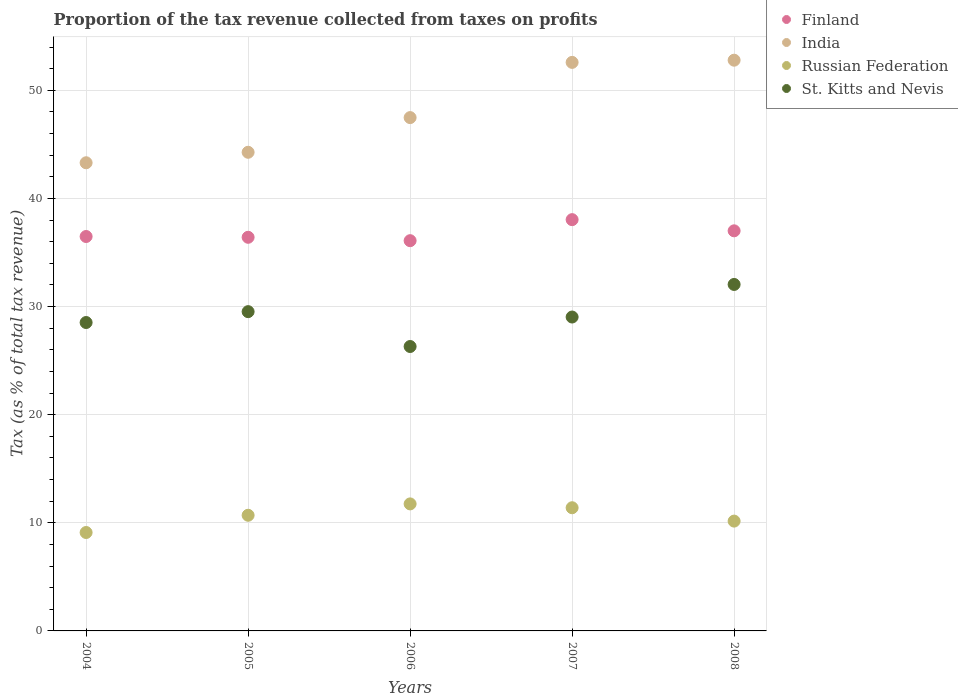How many different coloured dotlines are there?
Your response must be concise. 4. Is the number of dotlines equal to the number of legend labels?
Give a very brief answer. Yes. What is the proportion of the tax revenue collected in India in 2004?
Your response must be concise. 43.3. Across all years, what is the maximum proportion of the tax revenue collected in Finland?
Offer a very short reply. 38.03. Across all years, what is the minimum proportion of the tax revenue collected in India?
Give a very brief answer. 43.3. In which year was the proportion of the tax revenue collected in India maximum?
Keep it short and to the point. 2008. In which year was the proportion of the tax revenue collected in India minimum?
Ensure brevity in your answer.  2004. What is the total proportion of the tax revenue collected in Russian Federation in the graph?
Offer a terse response. 53.09. What is the difference between the proportion of the tax revenue collected in St. Kitts and Nevis in 2006 and that in 2007?
Provide a succinct answer. -2.73. What is the difference between the proportion of the tax revenue collected in St. Kitts and Nevis in 2004 and the proportion of the tax revenue collected in India in 2005?
Keep it short and to the point. -15.74. What is the average proportion of the tax revenue collected in Finland per year?
Provide a short and direct response. 36.8. In the year 2004, what is the difference between the proportion of the tax revenue collected in St. Kitts and Nevis and proportion of the tax revenue collected in Russian Federation?
Give a very brief answer. 19.42. In how many years, is the proportion of the tax revenue collected in India greater than 14 %?
Your answer should be compact. 5. What is the ratio of the proportion of the tax revenue collected in Russian Federation in 2006 to that in 2007?
Provide a short and direct response. 1.03. Is the proportion of the tax revenue collected in St. Kitts and Nevis in 2004 less than that in 2008?
Ensure brevity in your answer.  Yes. What is the difference between the highest and the second highest proportion of the tax revenue collected in Finland?
Your answer should be very brief. 1.03. What is the difference between the highest and the lowest proportion of the tax revenue collected in Russian Federation?
Keep it short and to the point. 2.65. In how many years, is the proportion of the tax revenue collected in India greater than the average proportion of the tax revenue collected in India taken over all years?
Offer a very short reply. 2. Is the sum of the proportion of the tax revenue collected in St. Kitts and Nevis in 2004 and 2006 greater than the maximum proportion of the tax revenue collected in Russian Federation across all years?
Keep it short and to the point. Yes. Is the proportion of the tax revenue collected in Finland strictly less than the proportion of the tax revenue collected in Russian Federation over the years?
Give a very brief answer. No. How many dotlines are there?
Give a very brief answer. 4. Does the graph contain grids?
Offer a terse response. Yes. How many legend labels are there?
Ensure brevity in your answer.  4. What is the title of the graph?
Keep it short and to the point. Proportion of the tax revenue collected from taxes on profits. What is the label or title of the Y-axis?
Your answer should be very brief. Tax (as % of total tax revenue). What is the Tax (as % of total tax revenue) of Finland in 2004?
Your answer should be compact. 36.48. What is the Tax (as % of total tax revenue) in India in 2004?
Your answer should be compact. 43.3. What is the Tax (as % of total tax revenue) in Russian Federation in 2004?
Offer a very short reply. 9.1. What is the Tax (as % of total tax revenue) of St. Kitts and Nevis in 2004?
Provide a short and direct response. 28.52. What is the Tax (as % of total tax revenue) of Finland in 2005?
Provide a succinct answer. 36.4. What is the Tax (as % of total tax revenue) in India in 2005?
Provide a succinct answer. 44.27. What is the Tax (as % of total tax revenue) of Russian Federation in 2005?
Give a very brief answer. 10.7. What is the Tax (as % of total tax revenue) in St. Kitts and Nevis in 2005?
Provide a succinct answer. 29.53. What is the Tax (as % of total tax revenue) in Finland in 2006?
Provide a succinct answer. 36.09. What is the Tax (as % of total tax revenue) in India in 2006?
Ensure brevity in your answer.  47.47. What is the Tax (as % of total tax revenue) in Russian Federation in 2006?
Keep it short and to the point. 11.75. What is the Tax (as % of total tax revenue) of St. Kitts and Nevis in 2006?
Ensure brevity in your answer.  26.3. What is the Tax (as % of total tax revenue) of Finland in 2007?
Your response must be concise. 38.03. What is the Tax (as % of total tax revenue) of India in 2007?
Make the answer very short. 52.58. What is the Tax (as % of total tax revenue) of Russian Federation in 2007?
Make the answer very short. 11.39. What is the Tax (as % of total tax revenue) in St. Kitts and Nevis in 2007?
Keep it short and to the point. 29.03. What is the Tax (as % of total tax revenue) in Finland in 2008?
Your answer should be compact. 37. What is the Tax (as % of total tax revenue) of India in 2008?
Your answer should be compact. 52.78. What is the Tax (as % of total tax revenue) of Russian Federation in 2008?
Provide a short and direct response. 10.16. What is the Tax (as % of total tax revenue) of St. Kitts and Nevis in 2008?
Offer a terse response. 32.04. Across all years, what is the maximum Tax (as % of total tax revenue) in Finland?
Make the answer very short. 38.03. Across all years, what is the maximum Tax (as % of total tax revenue) of India?
Offer a very short reply. 52.78. Across all years, what is the maximum Tax (as % of total tax revenue) in Russian Federation?
Provide a short and direct response. 11.75. Across all years, what is the maximum Tax (as % of total tax revenue) of St. Kitts and Nevis?
Provide a succinct answer. 32.04. Across all years, what is the minimum Tax (as % of total tax revenue) in Finland?
Offer a very short reply. 36.09. Across all years, what is the minimum Tax (as % of total tax revenue) of India?
Offer a terse response. 43.3. Across all years, what is the minimum Tax (as % of total tax revenue) of Russian Federation?
Your response must be concise. 9.1. Across all years, what is the minimum Tax (as % of total tax revenue) of St. Kitts and Nevis?
Ensure brevity in your answer.  26.3. What is the total Tax (as % of total tax revenue) of Finland in the graph?
Provide a succinct answer. 184.01. What is the total Tax (as % of total tax revenue) of India in the graph?
Your response must be concise. 240.39. What is the total Tax (as % of total tax revenue) in Russian Federation in the graph?
Your response must be concise. 53.09. What is the total Tax (as % of total tax revenue) of St. Kitts and Nevis in the graph?
Make the answer very short. 145.42. What is the difference between the Tax (as % of total tax revenue) of Finland in 2004 and that in 2005?
Provide a short and direct response. 0.07. What is the difference between the Tax (as % of total tax revenue) in India in 2004 and that in 2005?
Keep it short and to the point. -0.97. What is the difference between the Tax (as % of total tax revenue) of Russian Federation in 2004 and that in 2005?
Offer a terse response. -1.59. What is the difference between the Tax (as % of total tax revenue) in St. Kitts and Nevis in 2004 and that in 2005?
Your answer should be compact. -1.01. What is the difference between the Tax (as % of total tax revenue) in Finland in 2004 and that in 2006?
Make the answer very short. 0.39. What is the difference between the Tax (as % of total tax revenue) of India in 2004 and that in 2006?
Ensure brevity in your answer.  -4.18. What is the difference between the Tax (as % of total tax revenue) in Russian Federation in 2004 and that in 2006?
Offer a very short reply. -2.65. What is the difference between the Tax (as % of total tax revenue) in St. Kitts and Nevis in 2004 and that in 2006?
Offer a very short reply. 2.22. What is the difference between the Tax (as % of total tax revenue) of Finland in 2004 and that in 2007?
Ensure brevity in your answer.  -1.56. What is the difference between the Tax (as % of total tax revenue) in India in 2004 and that in 2007?
Offer a terse response. -9.28. What is the difference between the Tax (as % of total tax revenue) of Russian Federation in 2004 and that in 2007?
Offer a terse response. -2.29. What is the difference between the Tax (as % of total tax revenue) of St. Kitts and Nevis in 2004 and that in 2007?
Offer a very short reply. -0.51. What is the difference between the Tax (as % of total tax revenue) in Finland in 2004 and that in 2008?
Make the answer very short. -0.53. What is the difference between the Tax (as % of total tax revenue) in India in 2004 and that in 2008?
Provide a short and direct response. -9.49. What is the difference between the Tax (as % of total tax revenue) of Russian Federation in 2004 and that in 2008?
Give a very brief answer. -1.05. What is the difference between the Tax (as % of total tax revenue) in St. Kitts and Nevis in 2004 and that in 2008?
Your answer should be very brief. -3.52. What is the difference between the Tax (as % of total tax revenue) of Finland in 2005 and that in 2006?
Offer a terse response. 0.31. What is the difference between the Tax (as % of total tax revenue) of India in 2005 and that in 2006?
Keep it short and to the point. -3.21. What is the difference between the Tax (as % of total tax revenue) in Russian Federation in 2005 and that in 2006?
Your answer should be compact. -1.05. What is the difference between the Tax (as % of total tax revenue) in St. Kitts and Nevis in 2005 and that in 2006?
Offer a terse response. 3.22. What is the difference between the Tax (as % of total tax revenue) in Finland in 2005 and that in 2007?
Offer a very short reply. -1.63. What is the difference between the Tax (as % of total tax revenue) in India in 2005 and that in 2007?
Your answer should be very brief. -8.31. What is the difference between the Tax (as % of total tax revenue) of Russian Federation in 2005 and that in 2007?
Offer a very short reply. -0.7. What is the difference between the Tax (as % of total tax revenue) in St. Kitts and Nevis in 2005 and that in 2007?
Provide a succinct answer. 0.5. What is the difference between the Tax (as % of total tax revenue) of Finland in 2005 and that in 2008?
Offer a terse response. -0.6. What is the difference between the Tax (as % of total tax revenue) in India in 2005 and that in 2008?
Your response must be concise. -8.52. What is the difference between the Tax (as % of total tax revenue) of Russian Federation in 2005 and that in 2008?
Your answer should be compact. 0.54. What is the difference between the Tax (as % of total tax revenue) in St. Kitts and Nevis in 2005 and that in 2008?
Make the answer very short. -2.52. What is the difference between the Tax (as % of total tax revenue) of Finland in 2006 and that in 2007?
Provide a short and direct response. -1.94. What is the difference between the Tax (as % of total tax revenue) in India in 2006 and that in 2007?
Your response must be concise. -5.11. What is the difference between the Tax (as % of total tax revenue) in Russian Federation in 2006 and that in 2007?
Give a very brief answer. 0.36. What is the difference between the Tax (as % of total tax revenue) in St. Kitts and Nevis in 2006 and that in 2007?
Your answer should be very brief. -2.73. What is the difference between the Tax (as % of total tax revenue) in Finland in 2006 and that in 2008?
Ensure brevity in your answer.  -0.91. What is the difference between the Tax (as % of total tax revenue) of India in 2006 and that in 2008?
Ensure brevity in your answer.  -5.31. What is the difference between the Tax (as % of total tax revenue) in Russian Federation in 2006 and that in 2008?
Provide a short and direct response. 1.59. What is the difference between the Tax (as % of total tax revenue) in St. Kitts and Nevis in 2006 and that in 2008?
Your answer should be compact. -5.74. What is the difference between the Tax (as % of total tax revenue) of Finland in 2007 and that in 2008?
Offer a terse response. 1.03. What is the difference between the Tax (as % of total tax revenue) of India in 2007 and that in 2008?
Offer a terse response. -0.2. What is the difference between the Tax (as % of total tax revenue) in Russian Federation in 2007 and that in 2008?
Your answer should be compact. 1.24. What is the difference between the Tax (as % of total tax revenue) in St. Kitts and Nevis in 2007 and that in 2008?
Offer a terse response. -3.01. What is the difference between the Tax (as % of total tax revenue) of Finland in 2004 and the Tax (as % of total tax revenue) of India in 2005?
Your response must be concise. -7.79. What is the difference between the Tax (as % of total tax revenue) in Finland in 2004 and the Tax (as % of total tax revenue) in Russian Federation in 2005?
Your answer should be compact. 25.78. What is the difference between the Tax (as % of total tax revenue) in Finland in 2004 and the Tax (as % of total tax revenue) in St. Kitts and Nevis in 2005?
Offer a very short reply. 6.95. What is the difference between the Tax (as % of total tax revenue) of India in 2004 and the Tax (as % of total tax revenue) of Russian Federation in 2005?
Your response must be concise. 32.6. What is the difference between the Tax (as % of total tax revenue) of India in 2004 and the Tax (as % of total tax revenue) of St. Kitts and Nevis in 2005?
Provide a succinct answer. 13.77. What is the difference between the Tax (as % of total tax revenue) in Russian Federation in 2004 and the Tax (as % of total tax revenue) in St. Kitts and Nevis in 2005?
Your response must be concise. -20.42. What is the difference between the Tax (as % of total tax revenue) in Finland in 2004 and the Tax (as % of total tax revenue) in India in 2006?
Offer a terse response. -11. What is the difference between the Tax (as % of total tax revenue) of Finland in 2004 and the Tax (as % of total tax revenue) of Russian Federation in 2006?
Make the answer very short. 24.73. What is the difference between the Tax (as % of total tax revenue) of Finland in 2004 and the Tax (as % of total tax revenue) of St. Kitts and Nevis in 2006?
Your answer should be compact. 10.17. What is the difference between the Tax (as % of total tax revenue) in India in 2004 and the Tax (as % of total tax revenue) in Russian Federation in 2006?
Provide a succinct answer. 31.55. What is the difference between the Tax (as % of total tax revenue) in India in 2004 and the Tax (as % of total tax revenue) in St. Kitts and Nevis in 2006?
Provide a succinct answer. 16.99. What is the difference between the Tax (as % of total tax revenue) of Russian Federation in 2004 and the Tax (as % of total tax revenue) of St. Kitts and Nevis in 2006?
Provide a succinct answer. -17.2. What is the difference between the Tax (as % of total tax revenue) of Finland in 2004 and the Tax (as % of total tax revenue) of India in 2007?
Give a very brief answer. -16.1. What is the difference between the Tax (as % of total tax revenue) of Finland in 2004 and the Tax (as % of total tax revenue) of Russian Federation in 2007?
Keep it short and to the point. 25.08. What is the difference between the Tax (as % of total tax revenue) in Finland in 2004 and the Tax (as % of total tax revenue) in St. Kitts and Nevis in 2007?
Your answer should be compact. 7.45. What is the difference between the Tax (as % of total tax revenue) of India in 2004 and the Tax (as % of total tax revenue) of Russian Federation in 2007?
Keep it short and to the point. 31.9. What is the difference between the Tax (as % of total tax revenue) of India in 2004 and the Tax (as % of total tax revenue) of St. Kitts and Nevis in 2007?
Provide a short and direct response. 14.27. What is the difference between the Tax (as % of total tax revenue) of Russian Federation in 2004 and the Tax (as % of total tax revenue) of St. Kitts and Nevis in 2007?
Your answer should be compact. -19.93. What is the difference between the Tax (as % of total tax revenue) in Finland in 2004 and the Tax (as % of total tax revenue) in India in 2008?
Provide a short and direct response. -16.31. What is the difference between the Tax (as % of total tax revenue) of Finland in 2004 and the Tax (as % of total tax revenue) of Russian Federation in 2008?
Provide a short and direct response. 26.32. What is the difference between the Tax (as % of total tax revenue) of Finland in 2004 and the Tax (as % of total tax revenue) of St. Kitts and Nevis in 2008?
Ensure brevity in your answer.  4.43. What is the difference between the Tax (as % of total tax revenue) in India in 2004 and the Tax (as % of total tax revenue) in Russian Federation in 2008?
Ensure brevity in your answer.  33.14. What is the difference between the Tax (as % of total tax revenue) in India in 2004 and the Tax (as % of total tax revenue) in St. Kitts and Nevis in 2008?
Offer a terse response. 11.25. What is the difference between the Tax (as % of total tax revenue) in Russian Federation in 2004 and the Tax (as % of total tax revenue) in St. Kitts and Nevis in 2008?
Offer a terse response. -22.94. What is the difference between the Tax (as % of total tax revenue) of Finland in 2005 and the Tax (as % of total tax revenue) of India in 2006?
Offer a terse response. -11.07. What is the difference between the Tax (as % of total tax revenue) in Finland in 2005 and the Tax (as % of total tax revenue) in Russian Federation in 2006?
Your answer should be compact. 24.66. What is the difference between the Tax (as % of total tax revenue) in Finland in 2005 and the Tax (as % of total tax revenue) in St. Kitts and Nevis in 2006?
Provide a succinct answer. 10.1. What is the difference between the Tax (as % of total tax revenue) of India in 2005 and the Tax (as % of total tax revenue) of Russian Federation in 2006?
Make the answer very short. 32.52. What is the difference between the Tax (as % of total tax revenue) in India in 2005 and the Tax (as % of total tax revenue) in St. Kitts and Nevis in 2006?
Keep it short and to the point. 17.96. What is the difference between the Tax (as % of total tax revenue) of Russian Federation in 2005 and the Tax (as % of total tax revenue) of St. Kitts and Nevis in 2006?
Ensure brevity in your answer.  -15.61. What is the difference between the Tax (as % of total tax revenue) in Finland in 2005 and the Tax (as % of total tax revenue) in India in 2007?
Make the answer very short. -16.18. What is the difference between the Tax (as % of total tax revenue) in Finland in 2005 and the Tax (as % of total tax revenue) in Russian Federation in 2007?
Provide a succinct answer. 25.01. What is the difference between the Tax (as % of total tax revenue) in Finland in 2005 and the Tax (as % of total tax revenue) in St. Kitts and Nevis in 2007?
Your response must be concise. 7.37. What is the difference between the Tax (as % of total tax revenue) of India in 2005 and the Tax (as % of total tax revenue) of Russian Federation in 2007?
Keep it short and to the point. 32.87. What is the difference between the Tax (as % of total tax revenue) of India in 2005 and the Tax (as % of total tax revenue) of St. Kitts and Nevis in 2007?
Make the answer very short. 15.24. What is the difference between the Tax (as % of total tax revenue) of Russian Federation in 2005 and the Tax (as % of total tax revenue) of St. Kitts and Nevis in 2007?
Ensure brevity in your answer.  -18.33. What is the difference between the Tax (as % of total tax revenue) in Finland in 2005 and the Tax (as % of total tax revenue) in India in 2008?
Provide a short and direct response. -16.38. What is the difference between the Tax (as % of total tax revenue) in Finland in 2005 and the Tax (as % of total tax revenue) in Russian Federation in 2008?
Make the answer very short. 26.25. What is the difference between the Tax (as % of total tax revenue) of Finland in 2005 and the Tax (as % of total tax revenue) of St. Kitts and Nevis in 2008?
Give a very brief answer. 4.36. What is the difference between the Tax (as % of total tax revenue) in India in 2005 and the Tax (as % of total tax revenue) in Russian Federation in 2008?
Your response must be concise. 34.11. What is the difference between the Tax (as % of total tax revenue) in India in 2005 and the Tax (as % of total tax revenue) in St. Kitts and Nevis in 2008?
Make the answer very short. 12.22. What is the difference between the Tax (as % of total tax revenue) of Russian Federation in 2005 and the Tax (as % of total tax revenue) of St. Kitts and Nevis in 2008?
Provide a short and direct response. -21.35. What is the difference between the Tax (as % of total tax revenue) of Finland in 2006 and the Tax (as % of total tax revenue) of India in 2007?
Give a very brief answer. -16.49. What is the difference between the Tax (as % of total tax revenue) of Finland in 2006 and the Tax (as % of total tax revenue) of Russian Federation in 2007?
Give a very brief answer. 24.7. What is the difference between the Tax (as % of total tax revenue) in Finland in 2006 and the Tax (as % of total tax revenue) in St. Kitts and Nevis in 2007?
Your response must be concise. 7.06. What is the difference between the Tax (as % of total tax revenue) in India in 2006 and the Tax (as % of total tax revenue) in Russian Federation in 2007?
Offer a terse response. 36.08. What is the difference between the Tax (as % of total tax revenue) in India in 2006 and the Tax (as % of total tax revenue) in St. Kitts and Nevis in 2007?
Your answer should be very brief. 18.44. What is the difference between the Tax (as % of total tax revenue) of Russian Federation in 2006 and the Tax (as % of total tax revenue) of St. Kitts and Nevis in 2007?
Your answer should be very brief. -17.28. What is the difference between the Tax (as % of total tax revenue) in Finland in 2006 and the Tax (as % of total tax revenue) in India in 2008?
Ensure brevity in your answer.  -16.69. What is the difference between the Tax (as % of total tax revenue) in Finland in 2006 and the Tax (as % of total tax revenue) in Russian Federation in 2008?
Your answer should be compact. 25.93. What is the difference between the Tax (as % of total tax revenue) in Finland in 2006 and the Tax (as % of total tax revenue) in St. Kitts and Nevis in 2008?
Your response must be concise. 4.05. What is the difference between the Tax (as % of total tax revenue) in India in 2006 and the Tax (as % of total tax revenue) in Russian Federation in 2008?
Provide a succinct answer. 37.32. What is the difference between the Tax (as % of total tax revenue) of India in 2006 and the Tax (as % of total tax revenue) of St. Kitts and Nevis in 2008?
Ensure brevity in your answer.  15.43. What is the difference between the Tax (as % of total tax revenue) in Russian Federation in 2006 and the Tax (as % of total tax revenue) in St. Kitts and Nevis in 2008?
Offer a terse response. -20.29. What is the difference between the Tax (as % of total tax revenue) in Finland in 2007 and the Tax (as % of total tax revenue) in India in 2008?
Provide a short and direct response. -14.75. What is the difference between the Tax (as % of total tax revenue) of Finland in 2007 and the Tax (as % of total tax revenue) of Russian Federation in 2008?
Provide a short and direct response. 27.88. What is the difference between the Tax (as % of total tax revenue) in Finland in 2007 and the Tax (as % of total tax revenue) in St. Kitts and Nevis in 2008?
Your answer should be compact. 5.99. What is the difference between the Tax (as % of total tax revenue) in India in 2007 and the Tax (as % of total tax revenue) in Russian Federation in 2008?
Make the answer very short. 42.42. What is the difference between the Tax (as % of total tax revenue) in India in 2007 and the Tax (as % of total tax revenue) in St. Kitts and Nevis in 2008?
Make the answer very short. 20.54. What is the difference between the Tax (as % of total tax revenue) in Russian Federation in 2007 and the Tax (as % of total tax revenue) in St. Kitts and Nevis in 2008?
Keep it short and to the point. -20.65. What is the average Tax (as % of total tax revenue) in Finland per year?
Keep it short and to the point. 36.8. What is the average Tax (as % of total tax revenue) of India per year?
Make the answer very short. 48.08. What is the average Tax (as % of total tax revenue) of Russian Federation per year?
Give a very brief answer. 10.62. What is the average Tax (as % of total tax revenue) of St. Kitts and Nevis per year?
Give a very brief answer. 29.08. In the year 2004, what is the difference between the Tax (as % of total tax revenue) of Finland and Tax (as % of total tax revenue) of India?
Your answer should be very brief. -6.82. In the year 2004, what is the difference between the Tax (as % of total tax revenue) of Finland and Tax (as % of total tax revenue) of Russian Federation?
Keep it short and to the point. 27.37. In the year 2004, what is the difference between the Tax (as % of total tax revenue) in Finland and Tax (as % of total tax revenue) in St. Kitts and Nevis?
Your answer should be very brief. 7.96. In the year 2004, what is the difference between the Tax (as % of total tax revenue) of India and Tax (as % of total tax revenue) of Russian Federation?
Give a very brief answer. 34.19. In the year 2004, what is the difference between the Tax (as % of total tax revenue) of India and Tax (as % of total tax revenue) of St. Kitts and Nevis?
Offer a terse response. 14.78. In the year 2004, what is the difference between the Tax (as % of total tax revenue) of Russian Federation and Tax (as % of total tax revenue) of St. Kitts and Nevis?
Give a very brief answer. -19.42. In the year 2005, what is the difference between the Tax (as % of total tax revenue) of Finland and Tax (as % of total tax revenue) of India?
Give a very brief answer. -7.86. In the year 2005, what is the difference between the Tax (as % of total tax revenue) in Finland and Tax (as % of total tax revenue) in Russian Federation?
Your answer should be very brief. 25.71. In the year 2005, what is the difference between the Tax (as % of total tax revenue) in Finland and Tax (as % of total tax revenue) in St. Kitts and Nevis?
Your answer should be very brief. 6.88. In the year 2005, what is the difference between the Tax (as % of total tax revenue) of India and Tax (as % of total tax revenue) of Russian Federation?
Your response must be concise. 33.57. In the year 2005, what is the difference between the Tax (as % of total tax revenue) of India and Tax (as % of total tax revenue) of St. Kitts and Nevis?
Offer a very short reply. 14.74. In the year 2005, what is the difference between the Tax (as % of total tax revenue) in Russian Federation and Tax (as % of total tax revenue) in St. Kitts and Nevis?
Your answer should be compact. -18.83. In the year 2006, what is the difference between the Tax (as % of total tax revenue) of Finland and Tax (as % of total tax revenue) of India?
Your response must be concise. -11.38. In the year 2006, what is the difference between the Tax (as % of total tax revenue) of Finland and Tax (as % of total tax revenue) of Russian Federation?
Provide a short and direct response. 24.34. In the year 2006, what is the difference between the Tax (as % of total tax revenue) in Finland and Tax (as % of total tax revenue) in St. Kitts and Nevis?
Provide a short and direct response. 9.79. In the year 2006, what is the difference between the Tax (as % of total tax revenue) in India and Tax (as % of total tax revenue) in Russian Federation?
Give a very brief answer. 35.73. In the year 2006, what is the difference between the Tax (as % of total tax revenue) in India and Tax (as % of total tax revenue) in St. Kitts and Nevis?
Make the answer very short. 21.17. In the year 2006, what is the difference between the Tax (as % of total tax revenue) in Russian Federation and Tax (as % of total tax revenue) in St. Kitts and Nevis?
Your answer should be very brief. -14.56. In the year 2007, what is the difference between the Tax (as % of total tax revenue) in Finland and Tax (as % of total tax revenue) in India?
Offer a terse response. -14.54. In the year 2007, what is the difference between the Tax (as % of total tax revenue) of Finland and Tax (as % of total tax revenue) of Russian Federation?
Provide a short and direct response. 26.64. In the year 2007, what is the difference between the Tax (as % of total tax revenue) in Finland and Tax (as % of total tax revenue) in St. Kitts and Nevis?
Offer a terse response. 9.01. In the year 2007, what is the difference between the Tax (as % of total tax revenue) in India and Tax (as % of total tax revenue) in Russian Federation?
Make the answer very short. 41.19. In the year 2007, what is the difference between the Tax (as % of total tax revenue) of India and Tax (as % of total tax revenue) of St. Kitts and Nevis?
Your answer should be very brief. 23.55. In the year 2007, what is the difference between the Tax (as % of total tax revenue) of Russian Federation and Tax (as % of total tax revenue) of St. Kitts and Nevis?
Your answer should be very brief. -17.64. In the year 2008, what is the difference between the Tax (as % of total tax revenue) in Finland and Tax (as % of total tax revenue) in India?
Offer a very short reply. -15.78. In the year 2008, what is the difference between the Tax (as % of total tax revenue) of Finland and Tax (as % of total tax revenue) of Russian Federation?
Keep it short and to the point. 26.85. In the year 2008, what is the difference between the Tax (as % of total tax revenue) in Finland and Tax (as % of total tax revenue) in St. Kitts and Nevis?
Ensure brevity in your answer.  4.96. In the year 2008, what is the difference between the Tax (as % of total tax revenue) of India and Tax (as % of total tax revenue) of Russian Federation?
Make the answer very short. 42.63. In the year 2008, what is the difference between the Tax (as % of total tax revenue) in India and Tax (as % of total tax revenue) in St. Kitts and Nevis?
Your answer should be very brief. 20.74. In the year 2008, what is the difference between the Tax (as % of total tax revenue) of Russian Federation and Tax (as % of total tax revenue) of St. Kitts and Nevis?
Ensure brevity in your answer.  -21.89. What is the ratio of the Tax (as % of total tax revenue) of Finland in 2004 to that in 2005?
Offer a terse response. 1. What is the ratio of the Tax (as % of total tax revenue) of India in 2004 to that in 2005?
Provide a short and direct response. 0.98. What is the ratio of the Tax (as % of total tax revenue) in Russian Federation in 2004 to that in 2005?
Keep it short and to the point. 0.85. What is the ratio of the Tax (as % of total tax revenue) in St. Kitts and Nevis in 2004 to that in 2005?
Provide a short and direct response. 0.97. What is the ratio of the Tax (as % of total tax revenue) of Finland in 2004 to that in 2006?
Ensure brevity in your answer.  1.01. What is the ratio of the Tax (as % of total tax revenue) in India in 2004 to that in 2006?
Keep it short and to the point. 0.91. What is the ratio of the Tax (as % of total tax revenue) of Russian Federation in 2004 to that in 2006?
Your response must be concise. 0.77. What is the ratio of the Tax (as % of total tax revenue) in St. Kitts and Nevis in 2004 to that in 2006?
Provide a short and direct response. 1.08. What is the ratio of the Tax (as % of total tax revenue) in India in 2004 to that in 2007?
Your answer should be compact. 0.82. What is the ratio of the Tax (as % of total tax revenue) in Russian Federation in 2004 to that in 2007?
Give a very brief answer. 0.8. What is the ratio of the Tax (as % of total tax revenue) of St. Kitts and Nevis in 2004 to that in 2007?
Your answer should be very brief. 0.98. What is the ratio of the Tax (as % of total tax revenue) of Finland in 2004 to that in 2008?
Ensure brevity in your answer.  0.99. What is the ratio of the Tax (as % of total tax revenue) in India in 2004 to that in 2008?
Your answer should be compact. 0.82. What is the ratio of the Tax (as % of total tax revenue) of Russian Federation in 2004 to that in 2008?
Ensure brevity in your answer.  0.9. What is the ratio of the Tax (as % of total tax revenue) in St. Kitts and Nevis in 2004 to that in 2008?
Your answer should be compact. 0.89. What is the ratio of the Tax (as % of total tax revenue) of Finland in 2005 to that in 2006?
Provide a short and direct response. 1.01. What is the ratio of the Tax (as % of total tax revenue) of India in 2005 to that in 2006?
Ensure brevity in your answer.  0.93. What is the ratio of the Tax (as % of total tax revenue) of Russian Federation in 2005 to that in 2006?
Offer a very short reply. 0.91. What is the ratio of the Tax (as % of total tax revenue) of St. Kitts and Nevis in 2005 to that in 2006?
Provide a succinct answer. 1.12. What is the ratio of the Tax (as % of total tax revenue) of Finland in 2005 to that in 2007?
Make the answer very short. 0.96. What is the ratio of the Tax (as % of total tax revenue) of India in 2005 to that in 2007?
Provide a succinct answer. 0.84. What is the ratio of the Tax (as % of total tax revenue) of Russian Federation in 2005 to that in 2007?
Offer a terse response. 0.94. What is the ratio of the Tax (as % of total tax revenue) in St. Kitts and Nevis in 2005 to that in 2007?
Keep it short and to the point. 1.02. What is the ratio of the Tax (as % of total tax revenue) in Finland in 2005 to that in 2008?
Provide a succinct answer. 0.98. What is the ratio of the Tax (as % of total tax revenue) of India in 2005 to that in 2008?
Ensure brevity in your answer.  0.84. What is the ratio of the Tax (as % of total tax revenue) in Russian Federation in 2005 to that in 2008?
Offer a very short reply. 1.05. What is the ratio of the Tax (as % of total tax revenue) in St. Kitts and Nevis in 2005 to that in 2008?
Provide a succinct answer. 0.92. What is the ratio of the Tax (as % of total tax revenue) of Finland in 2006 to that in 2007?
Provide a short and direct response. 0.95. What is the ratio of the Tax (as % of total tax revenue) in India in 2006 to that in 2007?
Ensure brevity in your answer.  0.9. What is the ratio of the Tax (as % of total tax revenue) of Russian Federation in 2006 to that in 2007?
Provide a succinct answer. 1.03. What is the ratio of the Tax (as % of total tax revenue) of St. Kitts and Nevis in 2006 to that in 2007?
Make the answer very short. 0.91. What is the ratio of the Tax (as % of total tax revenue) of Finland in 2006 to that in 2008?
Provide a short and direct response. 0.98. What is the ratio of the Tax (as % of total tax revenue) in India in 2006 to that in 2008?
Your answer should be compact. 0.9. What is the ratio of the Tax (as % of total tax revenue) of Russian Federation in 2006 to that in 2008?
Offer a very short reply. 1.16. What is the ratio of the Tax (as % of total tax revenue) in St. Kitts and Nevis in 2006 to that in 2008?
Offer a terse response. 0.82. What is the ratio of the Tax (as % of total tax revenue) of Finland in 2007 to that in 2008?
Your answer should be compact. 1.03. What is the ratio of the Tax (as % of total tax revenue) of Russian Federation in 2007 to that in 2008?
Give a very brief answer. 1.12. What is the ratio of the Tax (as % of total tax revenue) in St. Kitts and Nevis in 2007 to that in 2008?
Keep it short and to the point. 0.91. What is the difference between the highest and the second highest Tax (as % of total tax revenue) in Finland?
Offer a very short reply. 1.03. What is the difference between the highest and the second highest Tax (as % of total tax revenue) in India?
Provide a succinct answer. 0.2. What is the difference between the highest and the second highest Tax (as % of total tax revenue) in Russian Federation?
Offer a very short reply. 0.36. What is the difference between the highest and the second highest Tax (as % of total tax revenue) in St. Kitts and Nevis?
Offer a terse response. 2.52. What is the difference between the highest and the lowest Tax (as % of total tax revenue) of Finland?
Your answer should be compact. 1.94. What is the difference between the highest and the lowest Tax (as % of total tax revenue) of India?
Provide a short and direct response. 9.49. What is the difference between the highest and the lowest Tax (as % of total tax revenue) of Russian Federation?
Your response must be concise. 2.65. What is the difference between the highest and the lowest Tax (as % of total tax revenue) of St. Kitts and Nevis?
Your response must be concise. 5.74. 